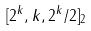Convert formula to latex. <formula><loc_0><loc_0><loc_500><loc_500>[ 2 ^ { k } , k , 2 ^ { k } / 2 ] _ { 2 }</formula> 